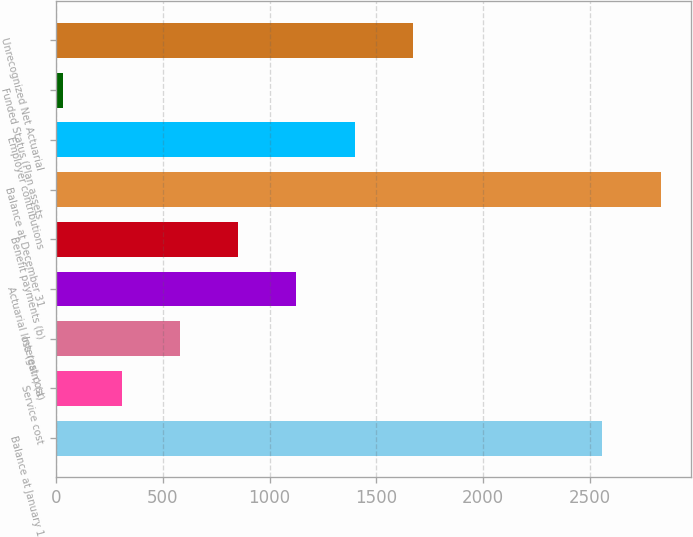<chart> <loc_0><loc_0><loc_500><loc_500><bar_chart><fcel>Balance at January 1<fcel>Service cost<fcel>Interest cost<fcel>Actuarial loss (gain) (a)<fcel>Benefit payments (b)<fcel>Balance at December 31<fcel>Employer contributions<fcel>Funded Status (Plan assets<fcel>Unrecognized Net Actuarial<nl><fcel>2560<fcel>306.2<fcel>579.4<fcel>1125.8<fcel>852.6<fcel>2833.2<fcel>1399<fcel>33<fcel>1672.2<nl></chart> 